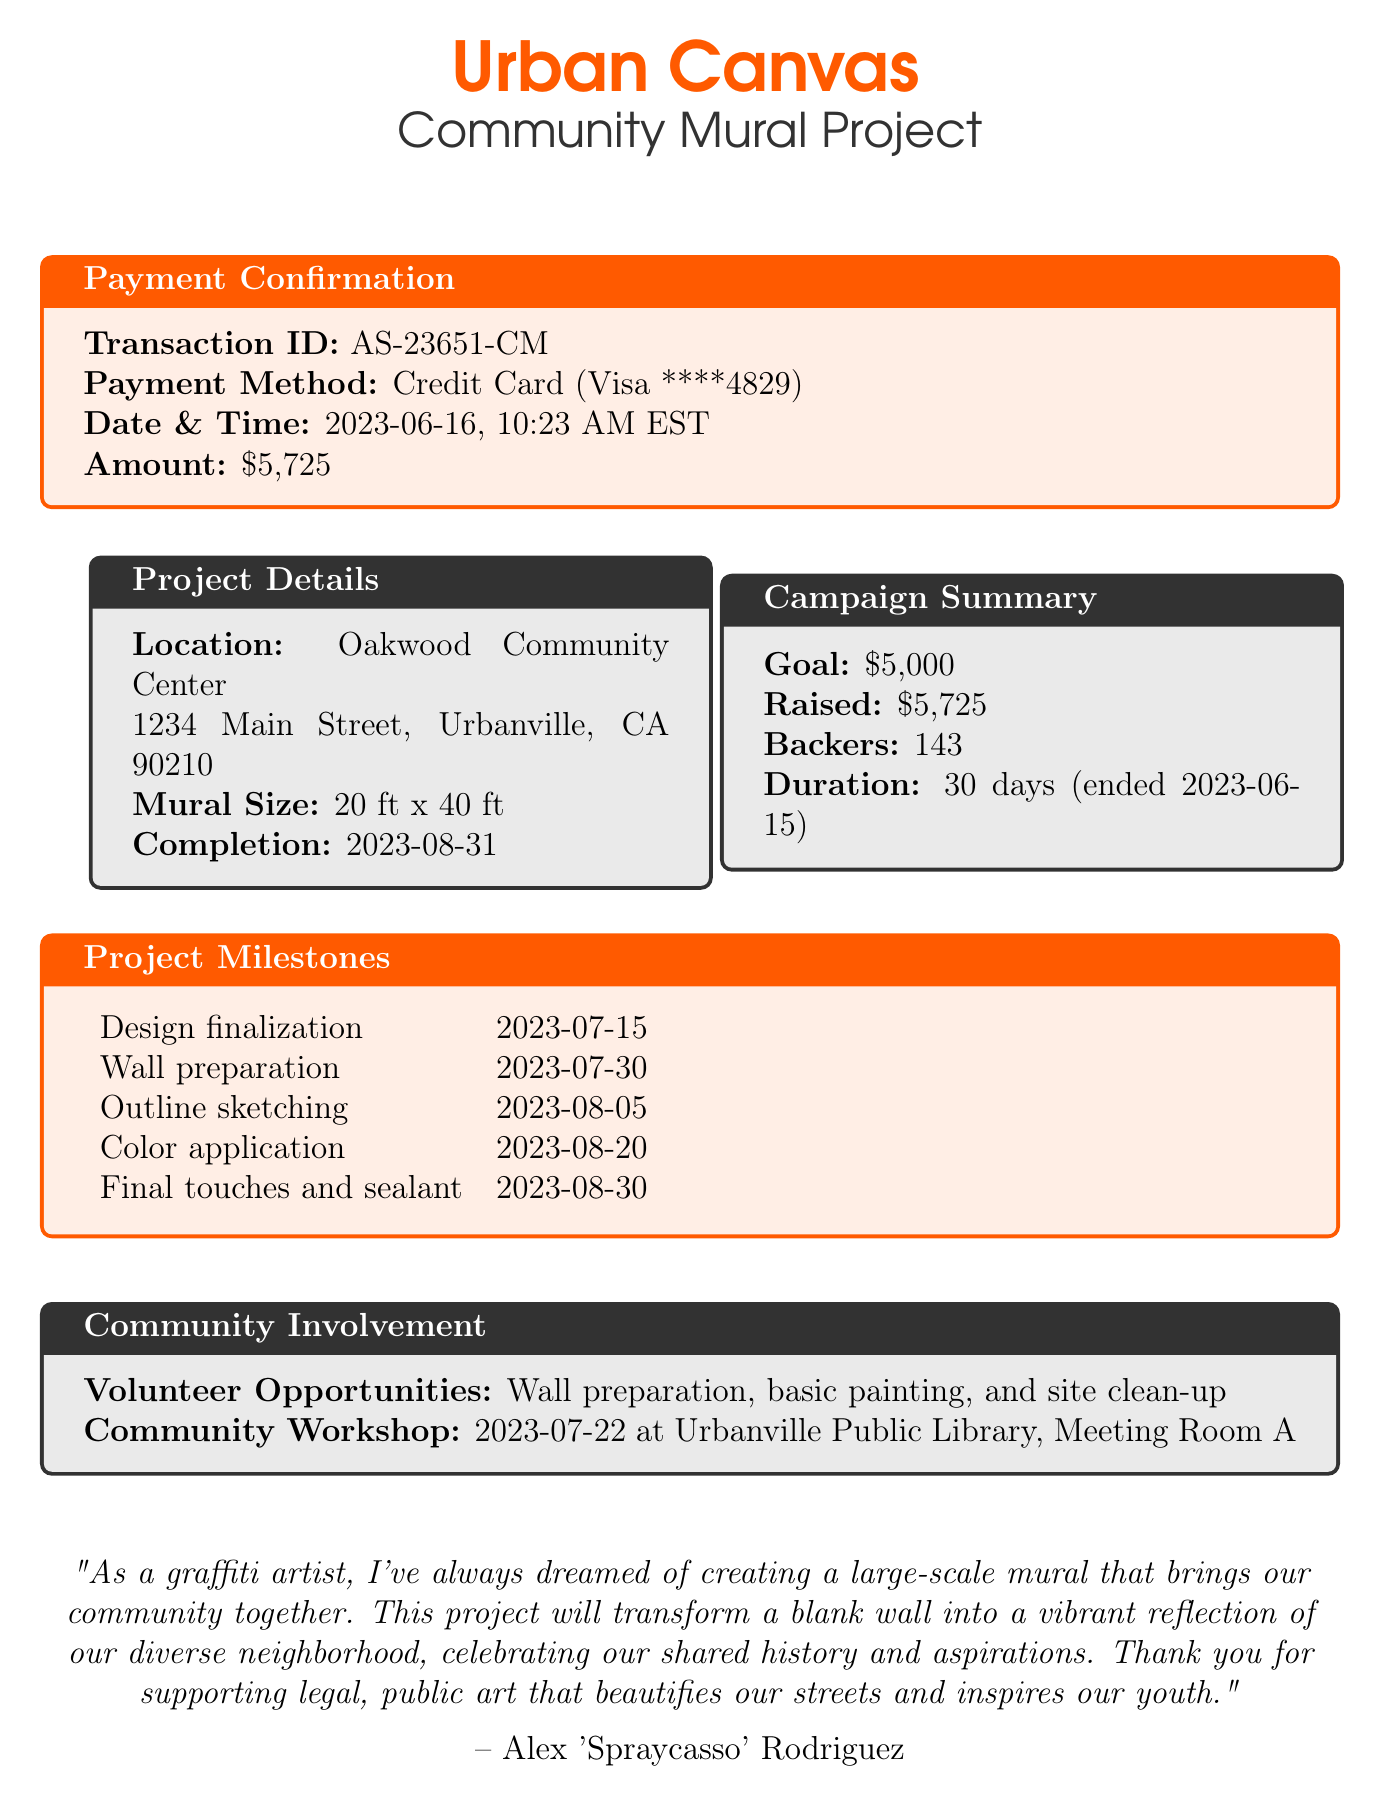What is the campaign name? The campaign name is clearly stated at the top of the document, which is "Urban Canvas: Community Mural Project".
Answer: Urban Canvas: Community Mural Project How much was the total raised? The total amount raised from the crowdfunding campaign is mentioned under the campaign summary section.
Answer: $5,725 What is the transaction ID? The transaction ID for the payment confirmation is specified in the payment confirmation box.
Answer: AS-23651-CM What payment method was used? The payment method used for the campaign is indicated in the payment confirmation section.
Answer: Credit Card When was the payment made? The payment date is provided in the payment confirmation box, indicating when the transaction occurred.
Answer: 2023-06-16 What is the mural size? The mural size is described under the project details section of the document.
Answer: 20 ft x 40 ft What is one of the volunteer opportunities? Volunteer opportunities are listed in the community involvement section of the document.
Answer: Wall preparation What milestone is scheduled for July 30? The specific milestone scheduled for July 30 is mentioned in the project milestones table.
Answer: Wall preparation How many backers supported the campaign? The total number of backers is highlighted in the campaign summary section.
Answer: 143 